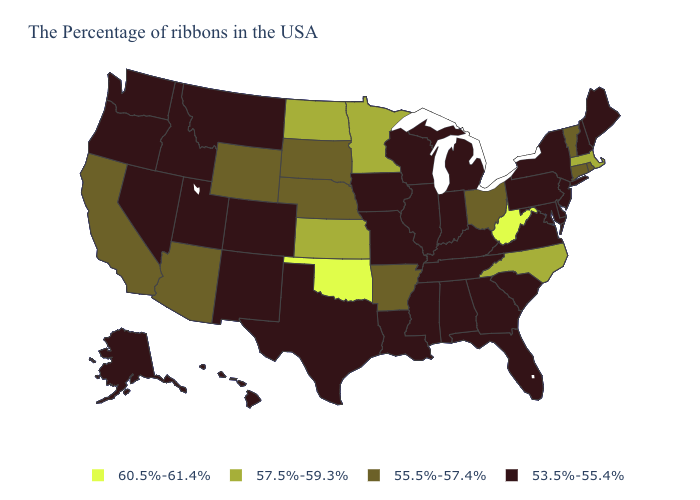Name the states that have a value in the range 60.5%-61.4%?
Quick response, please. West Virginia, Oklahoma. Name the states that have a value in the range 53.5%-55.4%?
Short answer required. Maine, New Hampshire, New York, New Jersey, Delaware, Maryland, Pennsylvania, Virginia, South Carolina, Florida, Georgia, Michigan, Kentucky, Indiana, Alabama, Tennessee, Wisconsin, Illinois, Mississippi, Louisiana, Missouri, Iowa, Texas, Colorado, New Mexico, Utah, Montana, Idaho, Nevada, Washington, Oregon, Alaska, Hawaii. Among the states that border Wisconsin , does Minnesota have the highest value?
Concise answer only. Yes. How many symbols are there in the legend?
Give a very brief answer. 4. What is the highest value in the MidWest ?
Answer briefly. 57.5%-59.3%. Is the legend a continuous bar?
Short answer required. No. Is the legend a continuous bar?
Quick response, please. No. What is the value of Nevada?
Quick response, please. 53.5%-55.4%. What is the value of Delaware?
Concise answer only. 53.5%-55.4%. What is the value of New Hampshire?
Be succinct. 53.5%-55.4%. What is the value of South Dakota?
Answer briefly. 55.5%-57.4%. What is the value of New Hampshire?
Be succinct. 53.5%-55.4%. Does Montana have the lowest value in the West?
Give a very brief answer. Yes. What is the value of Mississippi?
Short answer required. 53.5%-55.4%. Name the states that have a value in the range 53.5%-55.4%?
Concise answer only. Maine, New Hampshire, New York, New Jersey, Delaware, Maryland, Pennsylvania, Virginia, South Carolina, Florida, Georgia, Michigan, Kentucky, Indiana, Alabama, Tennessee, Wisconsin, Illinois, Mississippi, Louisiana, Missouri, Iowa, Texas, Colorado, New Mexico, Utah, Montana, Idaho, Nevada, Washington, Oregon, Alaska, Hawaii. 